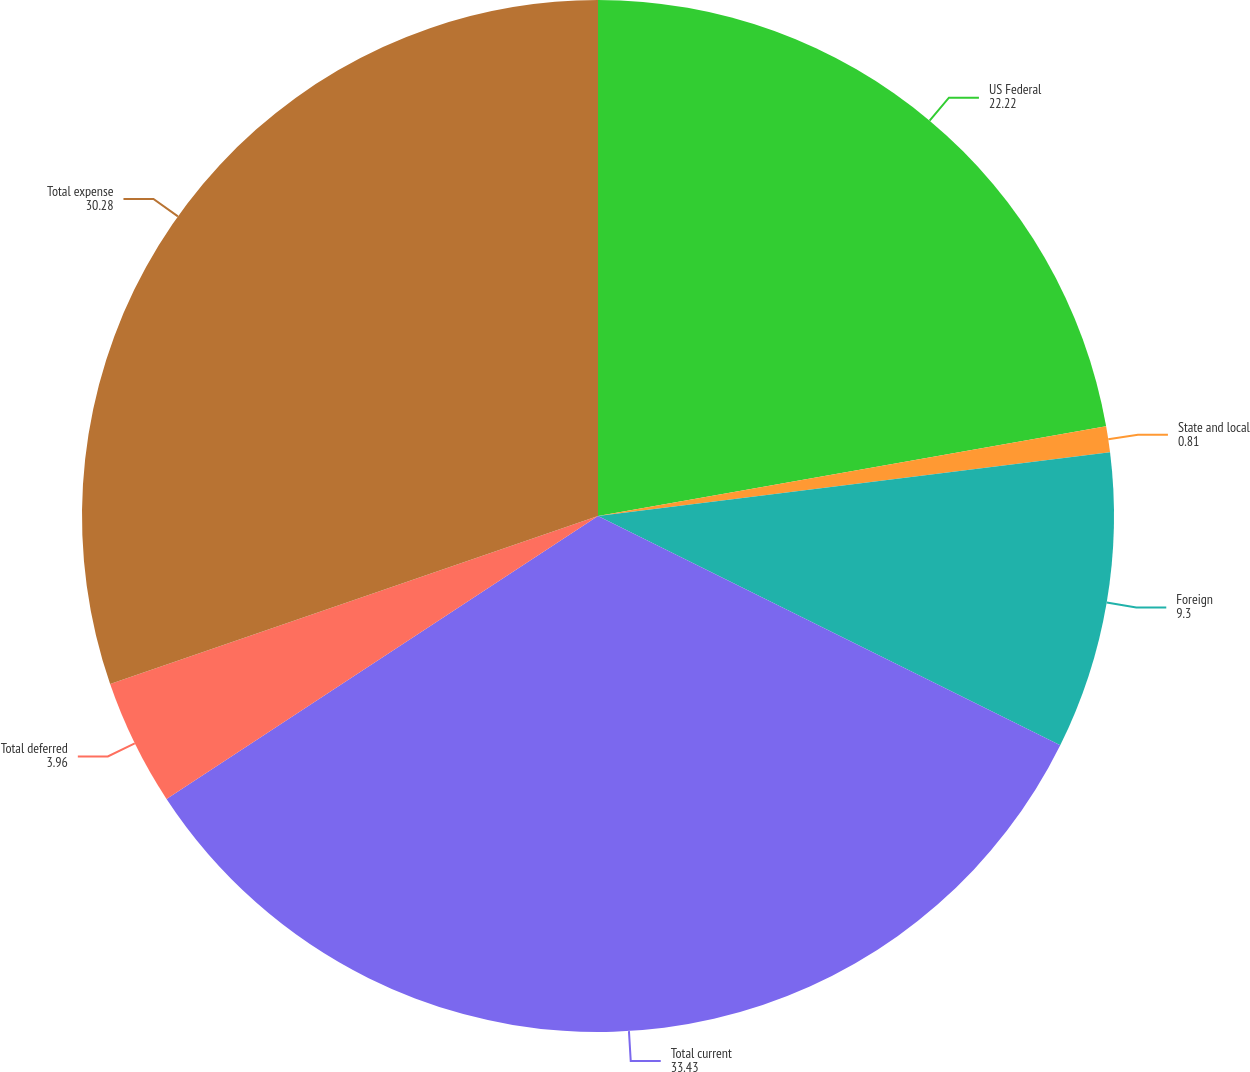<chart> <loc_0><loc_0><loc_500><loc_500><pie_chart><fcel>US Federal<fcel>State and local<fcel>Foreign<fcel>Total current<fcel>Total deferred<fcel>Total expense<nl><fcel>22.22%<fcel>0.81%<fcel>9.3%<fcel>33.43%<fcel>3.96%<fcel>30.28%<nl></chart> 